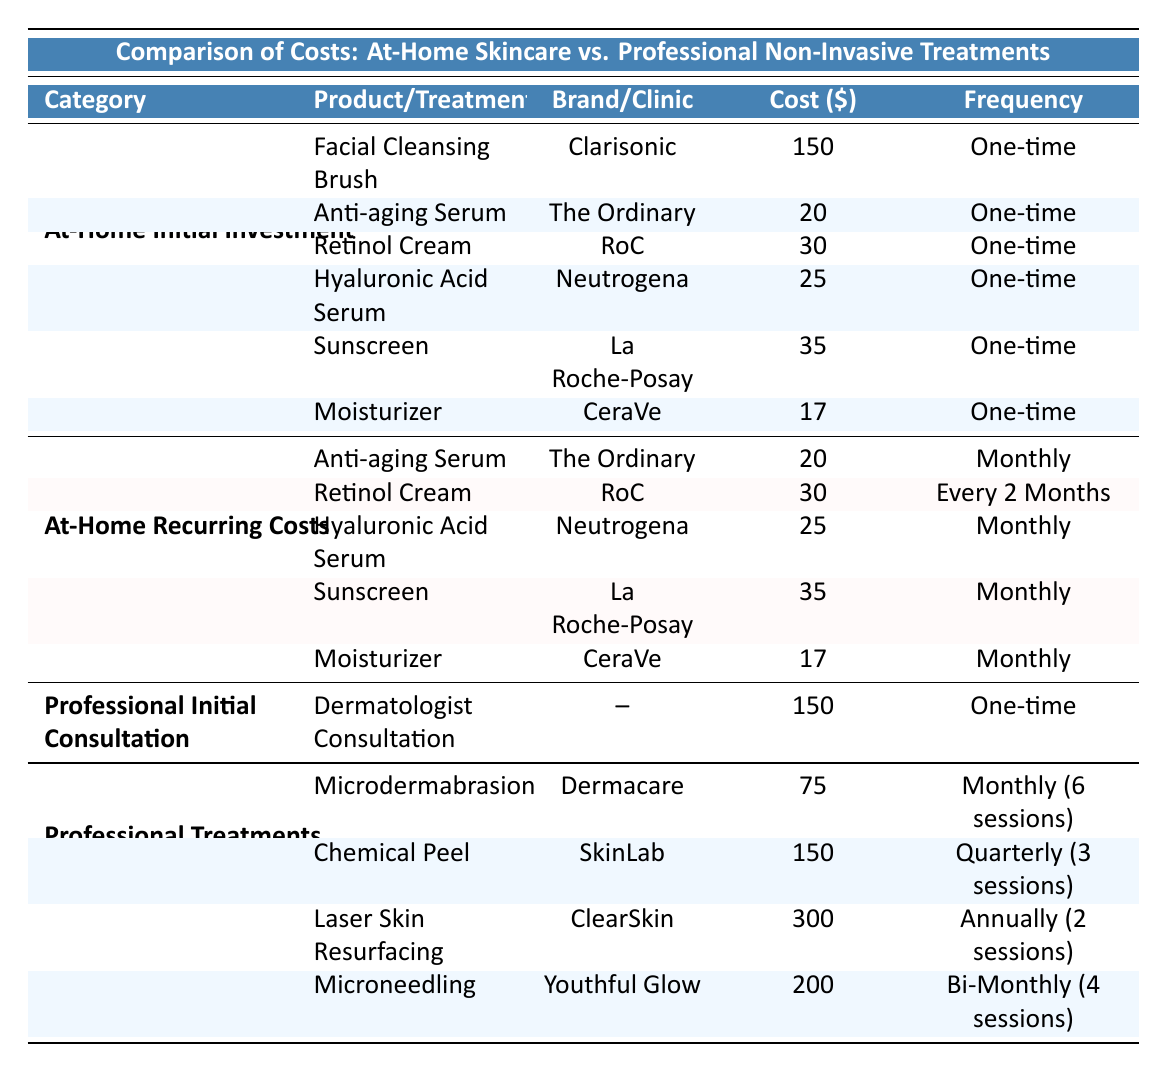What is the cost of the Facial Cleansing Brush? The table lists the initial investment costs, and under the "At-Home Initial Investment" category, it states that the cost of the Facial Cleansing Brush (brand Clarisonic) is 150.
Answer: 150 What is the frequency of purchasing the Anti-aging Serum? In the "At-Home Recurring Costs" section, the Anti-aging Serum by The Ordinary has a frequency of "Monthly".
Answer: Monthly How much do I need to spend on professional treatments in a year if I undergo Microdermabrasion monthly? The cost of a single session of Microdermabrasion is 75, and it is recommended to have 6 sessions in a year, which means I need to spend 75 * 6 = 450.
Answer: 450 Is the cost of a Microdermabrasion session more affordable than that of a Chemical Peel session? The table indicates that a single session of Microdermabrasion costs 75, while a Chemical Peel costs 150. Therefore, Microdermabrasion is less expensive since 75 is less than 150.
Answer: Yes What is the total initial investment for all at-home skincare products listed? We sum up the costs of all listed at-home skincare products: 150 (Cleansing Brush) + 20 (Anti-aging Serum) + 30 (Retinol Cream) + 25 (Hyaluronic Acid Serum) + 35 (Sunscreen) + 17 (Moisturizer) = 277.
Answer: 277 How much savings would I have in a year by choosing at-home skincare over professional treatments? If I choose at-home skincare, my total recurring annual costs would be calculated: 20 (Anti-aging Serum, 12 months) + 15 (Retinol Cream, 6 months) + 25 (Hyaluronic Acid Serum, 12 months) + 35 (Sunscreen, 12 months) + 17 (Moisturizer, 12 months) = 788. The cost of Microdermabrasion (450) is less than the total skincare costs (788), which means I would save: 788 - 450 = 338.
Answer: 338 How often should I visit a clinic for Chemical Peels? The table states that Chemical Peels are recommended every "Quarterly," which means every three months.
Answer: Quarterly Are there more products in the at-home skincare list than the number of professional treatments? There are 6 products listed under at-home skincare and 4 professional treatments listed. Since 6 is greater than 4, the answer is yes.
Answer: Yes What is the average cost of all professional treatments? To find the average, we add up the costs of all treatments: 75 (Microdermabrasion) + 150 (Chemical Peel) + 300 (Laser Skin Resurfacing) + 200 (Microneedling) = 725. Then divide by the number of treatments (4): 725 / 4 = 181.25.
Answer: 181.25 